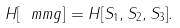Convert formula to latex. <formula><loc_0><loc_0><loc_500><loc_500>H [ \ m m { g } ] = H [ S _ { 1 } , S _ { 2 } , S _ { 3 } ] .</formula> 